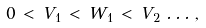<formula> <loc_0><loc_0><loc_500><loc_500>0 \, < \, V _ { 1 } \, < \, W _ { 1 } \, < \, V _ { 2 } \, \dots \, ,</formula> 